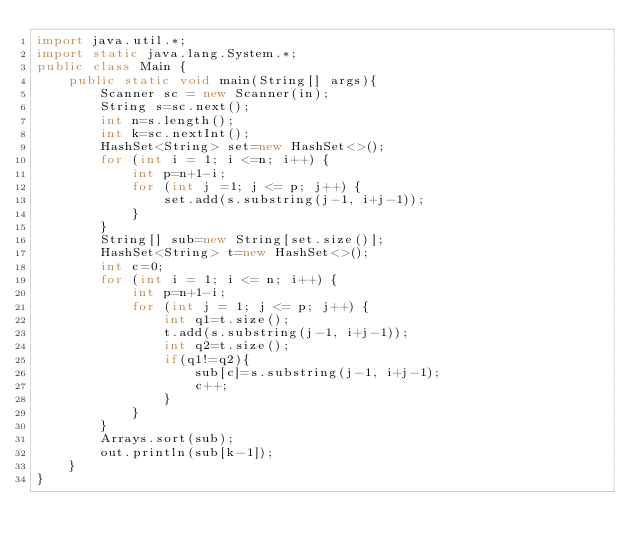Convert code to text. <code><loc_0><loc_0><loc_500><loc_500><_Java_>import java.util.*;
import static java.lang.System.*;
public class Main {
    public static void main(String[] args){
        Scanner sc = new Scanner(in);
        String s=sc.next();
        int n=s.length();
        int k=sc.nextInt();
        HashSet<String> set=new HashSet<>();
        for (int i = 1; i <=n; i++) {
            int p=n+1-i;
            for (int j =1; j <= p; j++) {
                set.add(s.substring(j-1, i+j-1));
            }
        }
        String[] sub=new String[set.size()];
        HashSet<String> t=new HashSet<>();
        int c=0;
        for (int i = 1; i <= n; i++) {
            int p=n+1-i;
            for (int j = 1; j <= p; j++) {
                int q1=t.size();
                t.add(s.substring(j-1, i+j-1));
                int q2=t.size();
                if(q1!=q2){
                    sub[c]=s.substring(j-1, i+j-1);
                    c++;
                }
            }
        }
        Arrays.sort(sub);
        out.println(sub[k-1]);
    }
}</code> 